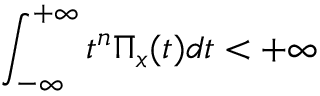<formula> <loc_0><loc_0><loc_500><loc_500>\int _ { - \infty } ^ { + \infty } t ^ { n } \Pi _ { x } ( t ) d t < + \infty</formula> 